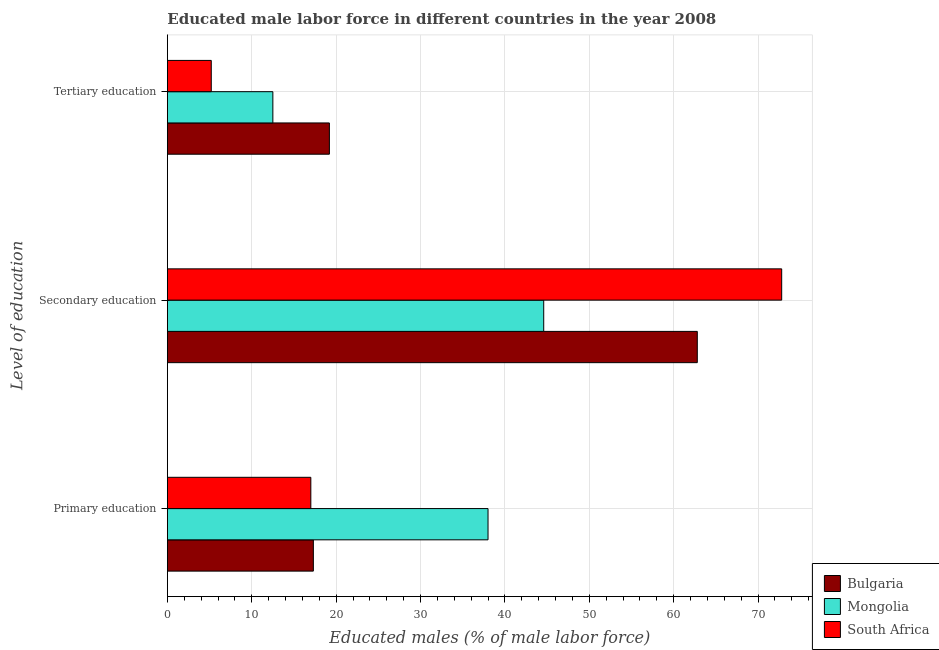How many different coloured bars are there?
Provide a short and direct response. 3. How many bars are there on the 2nd tick from the bottom?
Provide a succinct answer. 3. What is the label of the 3rd group of bars from the top?
Provide a succinct answer. Primary education. What is the percentage of male labor force who received primary education in Bulgaria?
Provide a succinct answer. 17.3. Across all countries, what is the minimum percentage of male labor force who received secondary education?
Offer a very short reply. 44.6. In which country was the percentage of male labor force who received secondary education maximum?
Keep it short and to the point. South Africa. In which country was the percentage of male labor force who received tertiary education minimum?
Provide a short and direct response. South Africa. What is the total percentage of male labor force who received secondary education in the graph?
Give a very brief answer. 180.2. What is the difference between the percentage of male labor force who received primary education in Mongolia and that in Bulgaria?
Provide a short and direct response. 20.7. What is the difference between the percentage of male labor force who received tertiary education in Mongolia and the percentage of male labor force who received primary education in South Africa?
Your response must be concise. -4.5. What is the average percentage of male labor force who received tertiary education per country?
Offer a very short reply. 12.3. What is the difference between the percentage of male labor force who received tertiary education and percentage of male labor force who received primary education in Bulgaria?
Provide a short and direct response. 1.9. What is the ratio of the percentage of male labor force who received primary education in Mongolia to that in Bulgaria?
Offer a very short reply. 2.2. What is the difference between the highest and the second highest percentage of male labor force who received primary education?
Your answer should be very brief. 20.7. In how many countries, is the percentage of male labor force who received secondary education greater than the average percentage of male labor force who received secondary education taken over all countries?
Make the answer very short. 2. Is the sum of the percentage of male labor force who received tertiary education in Bulgaria and Mongolia greater than the maximum percentage of male labor force who received secondary education across all countries?
Offer a terse response. No. What does the 1st bar from the top in Primary education represents?
Provide a short and direct response. South Africa. What does the 2nd bar from the bottom in Tertiary education represents?
Give a very brief answer. Mongolia. Is it the case that in every country, the sum of the percentage of male labor force who received primary education and percentage of male labor force who received secondary education is greater than the percentage of male labor force who received tertiary education?
Your answer should be compact. Yes. How many bars are there?
Ensure brevity in your answer.  9. How many countries are there in the graph?
Offer a very short reply. 3. What is the difference between two consecutive major ticks on the X-axis?
Provide a succinct answer. 10. How many legend labels are there?
Keep it short and to the point. 3. How are the legend labels stacked?
Provide a succinct answer. Vertical. What is the title of the graph?
Your response must be concise. Educated male labor force in different countries in the year 2008. Does "South Africa" appear as one of the legend labels in the graph?
Give a very brief answer. Yes. What is the label or title of the X-axis?
Provide a short and direct response. Educated males (% of male labor force). What is the label or title of the Y-axis?
Offer a terse response. Level of education. What is the Educated males (% of male labor force) of Bulgaria in Primary education?
Offer a very short reply. 17.3. What is the Educated males (% of male labor force) in Mongolia in Primary education?
Your response must be concise. 38. What is the Educated males (% of male labor force) in Bulgaria in Secondary education?
Provide a short and direct response. 62.8. What is the Educated males (% of male labor force) of Mongolia in Secondary education?
Provide a short and direct response. 44.6. What is the Educated males (% of male labor force) in South Africa in Secondary education?
Your answer should be very brief. 72.8. What is the Educated males (% of male labor force) in Bulgaria in Tertiary education?
Your answer should be compact. 19.2. What is the Educated males (% of male labor force) in South Africa in Tertiary education?
Your response must be concise. 5.2. Across all Level of education, what is the maximum Educated males (% of male labor force) of Bulgaria?
Your response must be concise. 62.8. Across all Level of education, what is the maximum Educated males (% of male labor force) in Mongolia?
Your answer should be very brief. 44.6. Across all Level of education, what is the maximum Educated males (% of male labor force) in South Africa?
Give a very brief answer. 72.8. Across all Level of education, what is the minimum Educated males (% of male labor force) in Bulgaria?
Your response must be concise. 17.3. Across all Level of education, what is the minimum Educated males (% of male labor force) of Mongolia?
Your answer should be compact. 12.5. Across all Level of education, what is the minimum Educated males (% of male labor force) in South Africa?
Ensure brevity in your answer.  5.2. What is the total Educated males (% of male labor force) of Bulgaria in the graph?
Keep it short and to the point. 99.3. What is the total Educated males (% of male labor force) of Mongolia in the graph?
Your answer should be very brief. 95.1. What is the total Educated males (% of male labor force) of South Africa in the graph?
Your answer should be very brief. 95. What is the difference between the Educated males (% of male labor force) in Bulgaria in Primary education and that in Secondary education?
Offer a terse response. -45.5. What is the difference between the Educated males (% of male labor force) of Mongolia in Primary education and that in Secondary education?
Offer a terse response. -6.6. What is the difference between the Educated males (% of male labor force) in South Africa in Primary education and that in Secondary education?
Offer a terse response. -55.8. What is the difference between the Educated males (% of male labor force) of South Africa in Primary education and that in Tertiary education?
Ensure brevity in your answer.  11.8. What is the difference between the Educated males (% of male labor force) of Bulgaria in Secondary education and that in Tertiary education?
Make the answer very short. 43.6. What is the difference between the Educated males (% of male labor force) in Mongolia in Secondary education and that in Tertiary education?
Your answer should be compact. 32.1. What is the difference between the Educated males (% of male labor force) in South Africa in Secondary education and that in Tertiary education?
Give a very brief answer. 67.6. What is the difference between the Educated males (% of male labor force) in Bulgaria in Primary education and the Educated males (% of male labor force) in Mongolia in Secondary education?
Keep it short and to the point. -27.3. What is the difference between the Educated males (% of male labor force) in Bulgaria in Primary education and the Educated males (% of male labor force) in South Africa in Secondary education?
Ensure brevity in your answer.  -55.5. What is the difference between the Educated males (% of male labor force) of Mongolia in Primary education and the Educated males (% of male labor force) of South Africa in Secondary education?
Give a very brief answer. -34.8. What is the difference between the Educated males (% of male labor force) of Bulgaria in Primary education and the Educated males (% of male labor force) of Mongolia in Tertiary education?
Your answer should be very brief. 4.8. What is the difference between the Educated males (% of male labor force) in Bulgaria in Primary education and the Educated males (% of male labor force) in South Africa in Tertiary education?
Make the answer very short. 12.1. What is the difference between the Educated males (% of male labor force) in Mongolia in Primary education and the Educated males (% of male labor force) in South Africa in Tertiary education?
Offer a terse response. 32.8. What is the difference between the Educated males (% of male labor force) in Bulgaria in Secondary education and the Educated males (% of male labor force) in Mongolia in Tertiary education?
Ensure brevity in your answer.  50.3. What is the difference between the Educated males (% of male labor force) in Bulgaria in Secondary education and the Educated males (% of male labor force) in South Africa in Tertiary education?
Your answer should be very brief. 57.6. What is the difference between the Educated males (% of male labor force) in Mongolia in Secondary education and the Educated males (% of male labor force) in South Africa in Tertiary education?
Offer a terse response. 39.4. What is the average Educated males (% of male labor force) in Bulgaria per Level of education?
Provide a short and direct response. 33.1. What is the average Educated males (% of male labor force) in Mongolia per Level of education?
Give a very brief answer. 31.7. What is the average Educated males (% of male labor force) of South Africa per Level of education?
Your answer should be compact. 31.67. What is the difference between the Educated males (% of male labor force) of Bulgaria and Educated males (% of male labor force) of Mongolia in Primary education?
Offer a terse response. -20.7. What is the difference between the Educated males (% of male labor force) in Mongolia and Educated males (% of male labor force) in South Africa in Primary education?
Offer a very short reply. 21. What is the difference between the Educated males (% of male labor force) in Mongolia and Educated males (% of male labor force) in South Africa in Secondary education?
Your response must be concise. -28.2. What is the difference between the Educated males (% of male labor force) of Bulgaria and Educated males (% of male labor force) of Mongolia in Tertiary education?
Keep it short and to the point. 6.7. What is the difference between the Educated males (% of male labor force) of Bulgaria and Educated males (% of male labor force) of South Africa in Tertiary education?
Your response must be concise. 14. What is the difference between the Educated males (% of male labor force) in Mongolia and Educated males (% of male labor force) in South Africa in Tertiary education?
Your response must be concise. 7.3. What is the ratio of the Educated males (% of male labor force) in Bulgaria in Primary education to that in Secondary education?
Make the answer very short. 0.28. What is the ratio of the Educated males (% of male labor force) of Mongolia in Primary education to that in Secondary education?
Ensure brevity in your answer.  0.85. What is the ratio of the Educated males (% of male labor force) of South Africa in Primary education to that in Secondary education?
Offer a very short reply. 0.23. What is the ratio of the Educated males (% of male labor force) in Bulgaria in Primary education to that in Tertiary education?
Make the answer very short. 0.9. What is the ratio of the Educated males (% of male labor force) in Mongolia in Primary education to that in Tertiary education?
Provide a succinct answer. 3.04. What is the ratio of the Educated males (% of male labor force) in South Africa in Primary education to that in Tertiary education?
Your answer should be compact. 3.27. What is the ratio of the Educated males (% of male labor force) in Bulgaria in Secondary education to that in Tertiary education?
Give a very brief answer. 3.27. What is the ratio of the Educated males (% of male labor force) in Mongolia in Secondary education to that in Tertiary education?
Keep it short and to the point. 3.57. What is the difference between the highest and the second highest Educated males (% of male labor force) in Bulgaria?
Offer a terse response. 43.6. What is the difference between the highest and the second highest Educated males (% of male labor force) in Mongolia?
Provide a succinct answer. 6.6. What is the difference between the highest and the second highest Educated males (% of male labor force) of South Africa?
Provide a short and direct response. 55.8. What is the difference between the highest and the lowest Educated males (% of male labor force) in Bulgaria?
Provide a short and direct response. 45.5. What is the difference between the highest and the lowest Educated males (% of male labor force) of Mongolia?
Offer a very short reply. 32.1. What is the difference between the highest and the lowest Educated males (% of male labor force) in South Africa?
Ensure brevity in your answer.  67.6. 